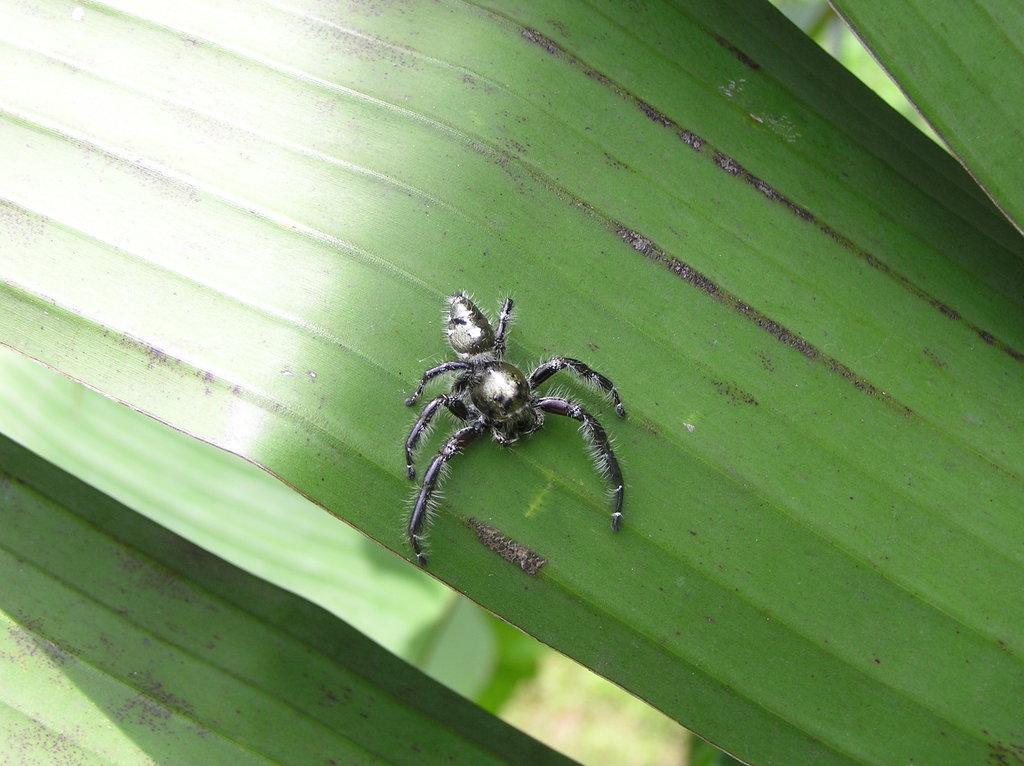In one or two sentences, can you explain what this image depicts? In the image there is an insect on a leaf. 